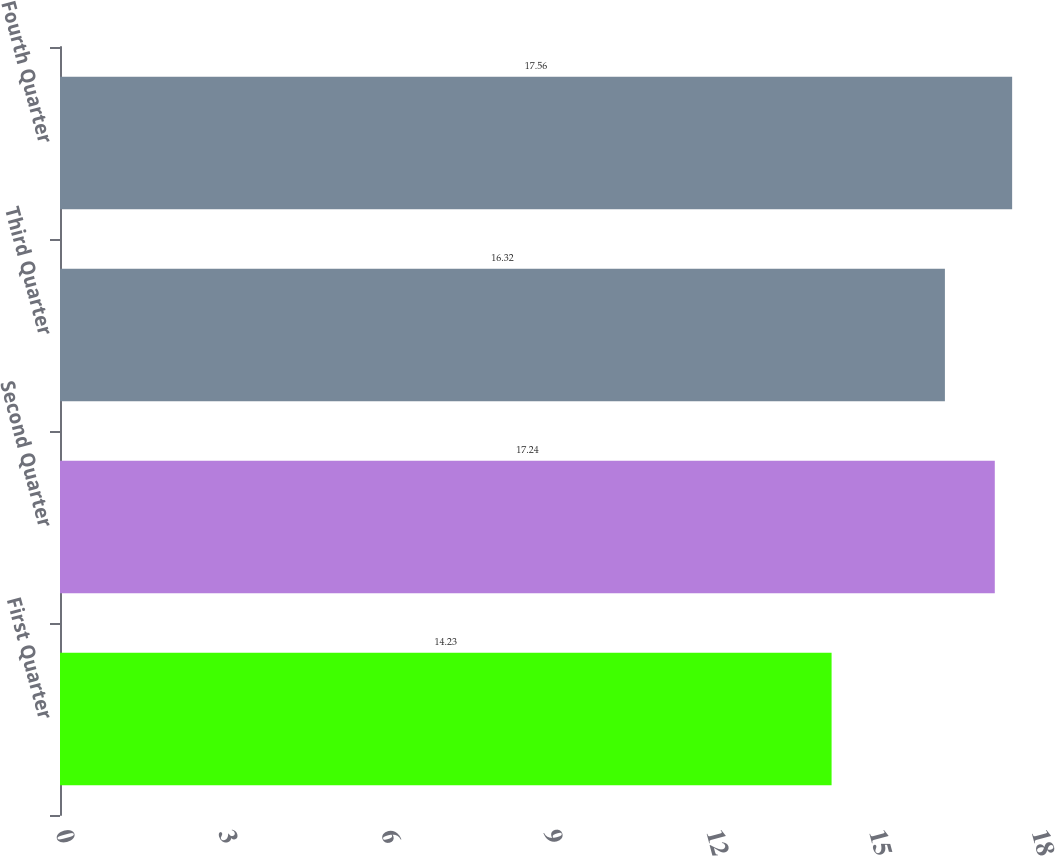Convert chart to OTSL. <chart><loc_0><loc_0><loc_500><loc_500><bar_chart><fcel>First Quarter<fcel>Second Quarter<fcel>Third Quarter<fcel>Fourth Quarter<nl><fcel>14.23<fcel>17.24<fcel>16.32<fcel>17.56<nl></chart> 